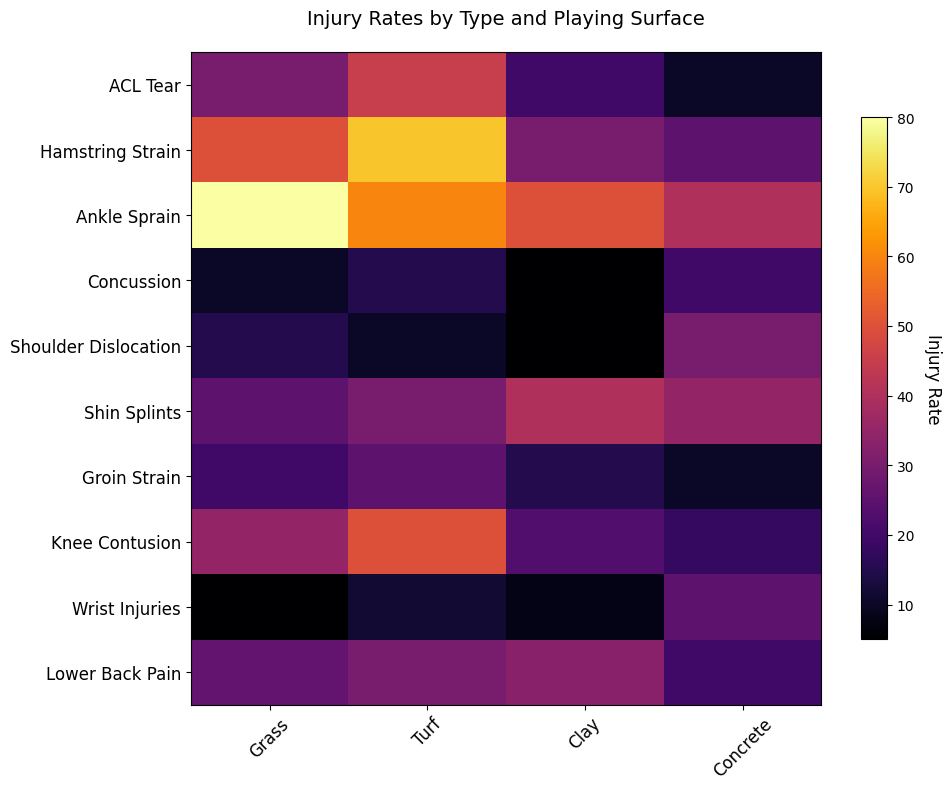Which injury type has the highest rate on concrete surfaces? The highest rate on concrete surfaces can be identified by looking at the row with the darkest color in the column labeled "Concrete" in the heatmap.
Answer: Shoulder Dislocation Between grass and turf surfaces, which has a higher rate of ACL Tears? To determine which surface has a higher rate, compare the colors in the "Grass" and "Turf" columns for the row labeled "ACL Tear".
Answer: Turf What is the total injury rate for Ankle Sprains across all surfaces? Sum the values in the row labeled "Ankle Sprain" across all columns: 80 (Grass) + 60 (Turf) + 50 (Clay) + 40 (Concrete) = 230
Answer: 230 Which two injury types have the same rate on grass surfaces? Look for rows with equal color intensity in the "Grass" column. The two rows with the same value (15) are "Shoulder Dislocation" and "Lower Back Pain".
Answer: Shoulder Dislocation and Lower Back Pain What is the average rate of injury for Groin Strain compared across grass, turf, clay, and concrete surfaces? Sum the values in the "Groin Strain" row (20 + 25 + 15 + 10 = 70) and divide by the number of surfaces (4): 70 / 4 = 17.5
Answer: 17.5 Comparing Knee Contusion on clay surface and concrete surface, which has the higher rate and what is the difference? Compare the values in the "Clay" and "Concrete" columns for the row labeled "Knee Contusion": 23 (Clay) and 18 (Concrete). The difference is 23 - 18 = 5.
Answer: Clay, 5 Which injury type has the lowest overall rate on all surfaces combined? Review the aggregate values for each injury type by summing their row values and identify the minimum. Calculations needed: ACL Tear (105), Hamstring Strain (175), Ankle Sprain (230), Concussion (50), Shoulder Dislocation (60), Shin Splints (130), Groin Strain (70), Knee Contusion (126), Wrist Injuries (50), Lower Back Pain (109). The lowest sum is for Concussion and Wrist Injuries (50).
Answer: Concussion and Wrist Injuries Which surface has the highest total injury rate across all injury types? Sum the values in each column and determine the maximum. Calculations: Grass (296), Turf (347), Clay (229), Concrete (233). Turf has the highest total at 347.
Answer: Turf Comparing the color intensity for shin splints on clay and concrete surfaces, which has a higher rate? Look at the color intensity in the "Shin Splints" row for the "Clay" and "Concrete" columns. The darker color indicates a higher rate.
Answer: Clay 